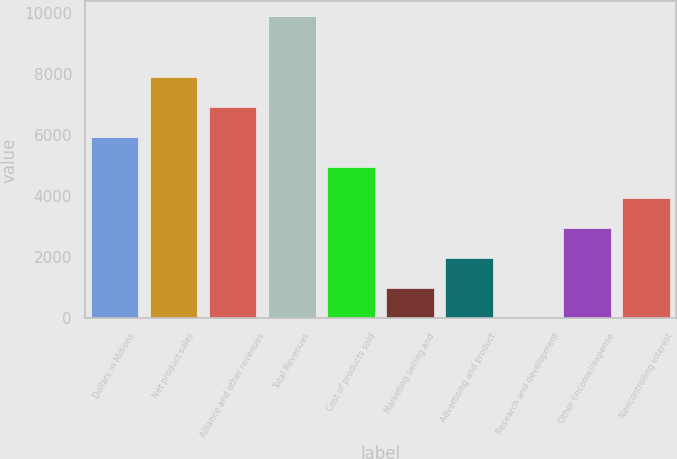Convert chart to OTSL. <chart><loc_0><loc_0><loc_500><loc_500><bar_chart><fcel>Dollars in Millions<fcel>Net product sales<fcel>Alliance and other revenues<fcel>Total Revenues<fcel>Cost of products sold<fcel>Marketing selling and<fcel>Advertising and product<fcel>Research and development<fcel>Other (income)/expense<fcel>Noncontrolling interest<nl><fcel>5924.8<fcel>7898.4<fcel>6911.6<fcel>9872<fcel>4938<fcel>990.8<fcel>1977.6<fcel>4<fcel>2964.4<fcel>3951.2<nl></chart> 